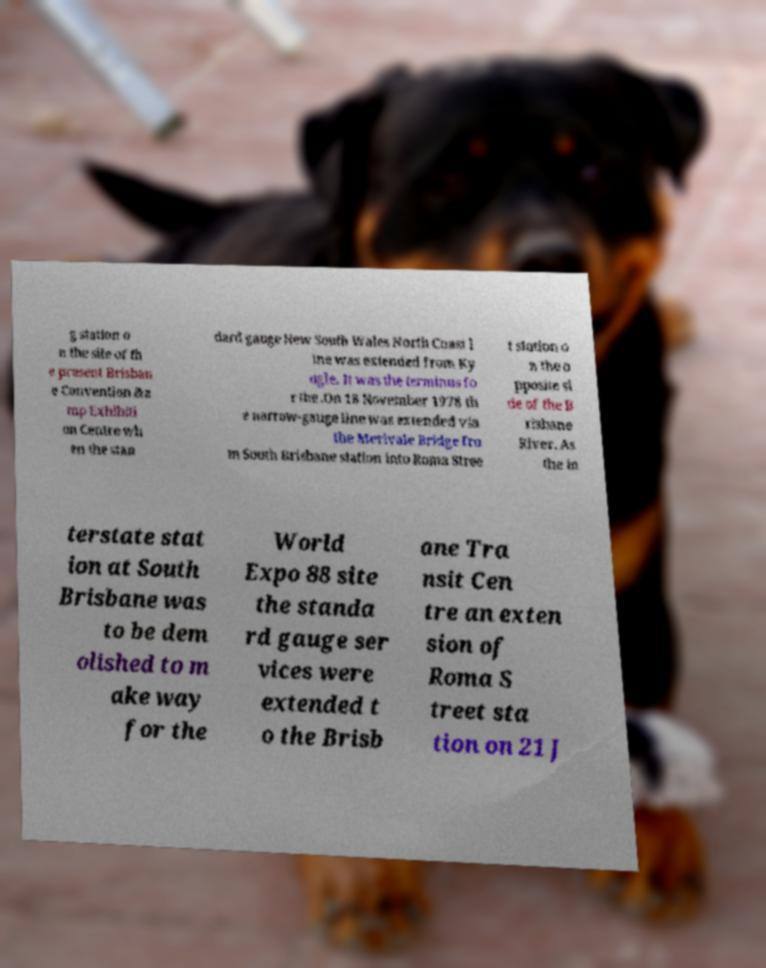What messages or text are displayed in this image? I need them in a readable, typed format. g station o n the site of th e present Brisban e Convention &a mp Exhibiti on Centre wh en the stan dard gauge New South Wales North Coast l ine was extended from Ky ogle. It was the terminus fo r the .On 18 November 1978 th e narrow-gauge line was extended via the Merivale Bridge fro m South Brisbane station into Roma Stree t station o n the o pposite si de of the B risbane River. As the in terstate stat ion at South Brisbane was to be dem olished to m ake way for the World Expo 88 site the standa rd gauge ser vices were extended t o the Brisb ane Tra nsit Cen tre an exten sion of Roma S treet sta tion on 21 J 